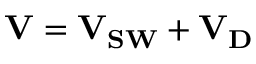<formula> <loc_0><loc_0><loc_500><loc_500>V = V _ { S W } + V _ { D }</formula> 